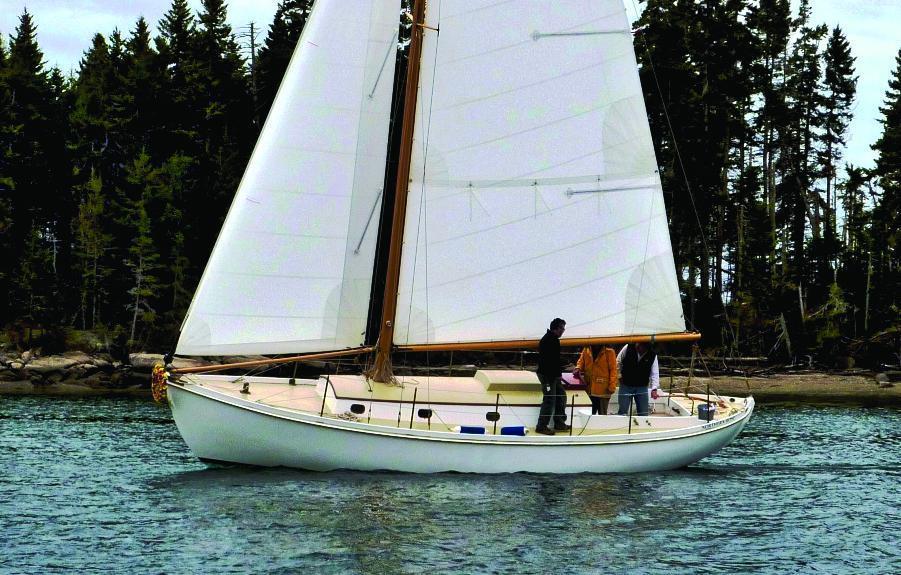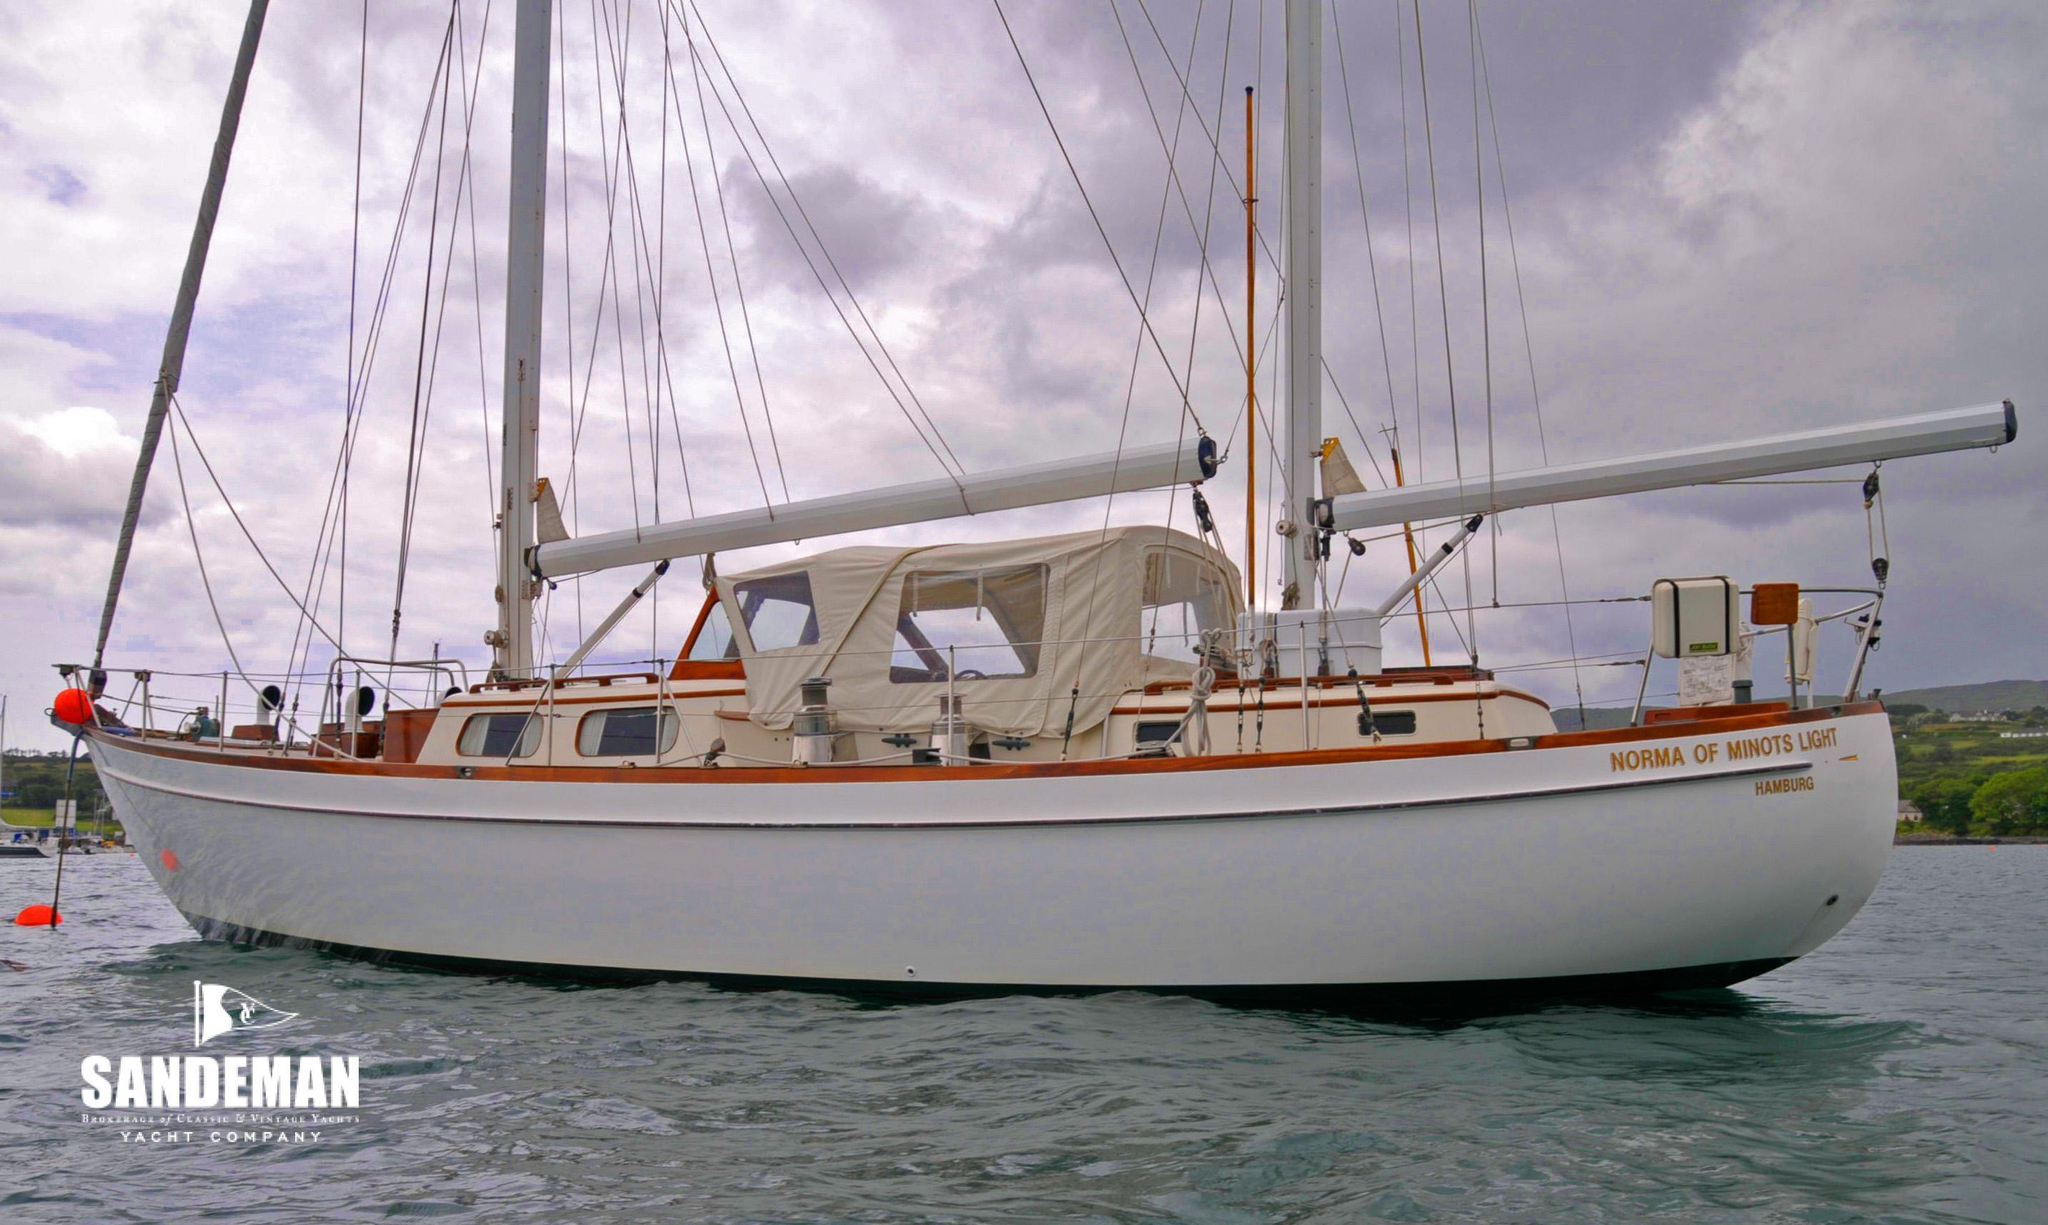The first image is the image on the left, the second image is the image on the right. Given the left and right images, does the statement "The left and right image contains a total of two sailboats in the water." hold true? Answer yes or no. Yes. The first image is the image on the left, the second image is the image on the right. Examine the images to the left and right. Is the description "A boat is tied up to a dock." accurate? Answer yes or no. No. 